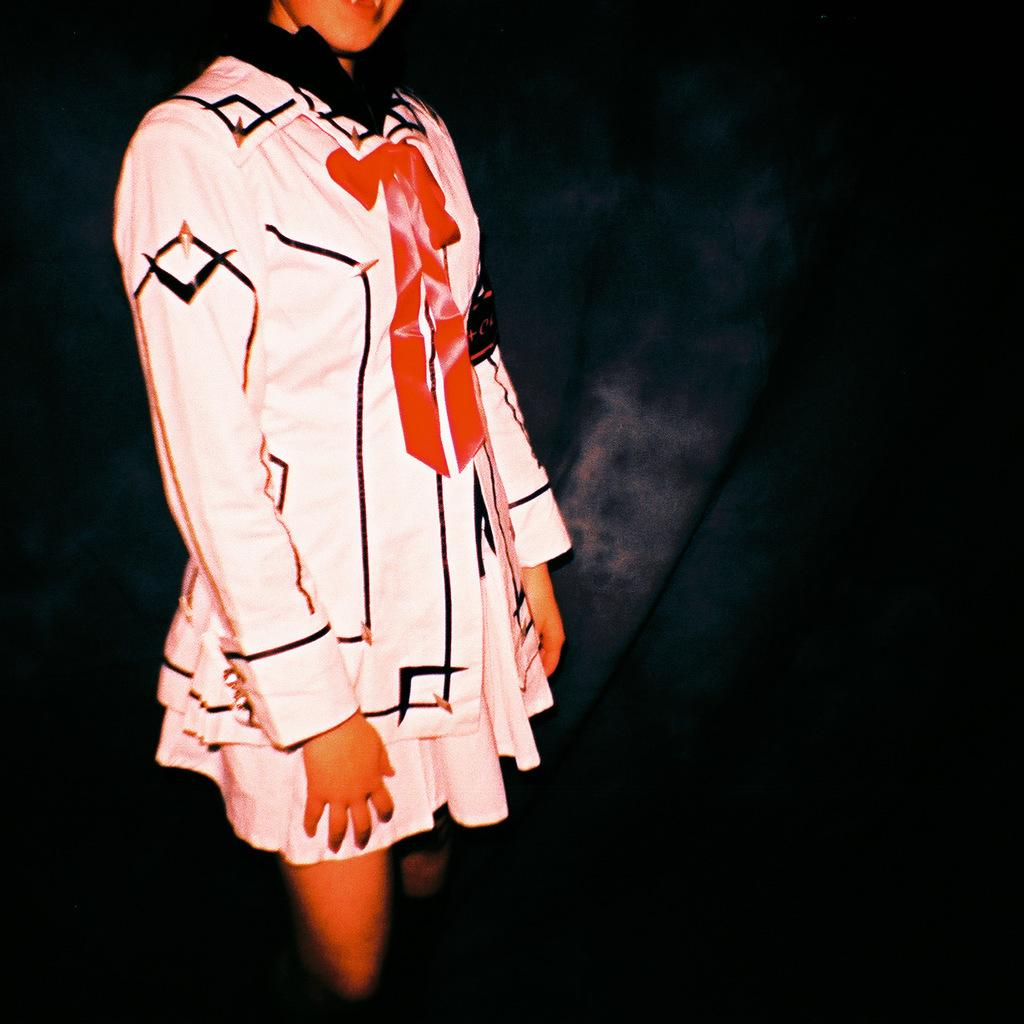Who is the main subject in the image? There is a woman in the image. What is the woman wearing? The woman is wearing a white dress. What is the woman doing in the image? The woman is standing. What can be observed about the background of the image? The background of the image is dark in color. Where is the woman sitting in the image? The woman is not sitting in the image; she is standing. What type of park can be seen in the background of the image? There is no park visible in the image; the background is dark in color. 